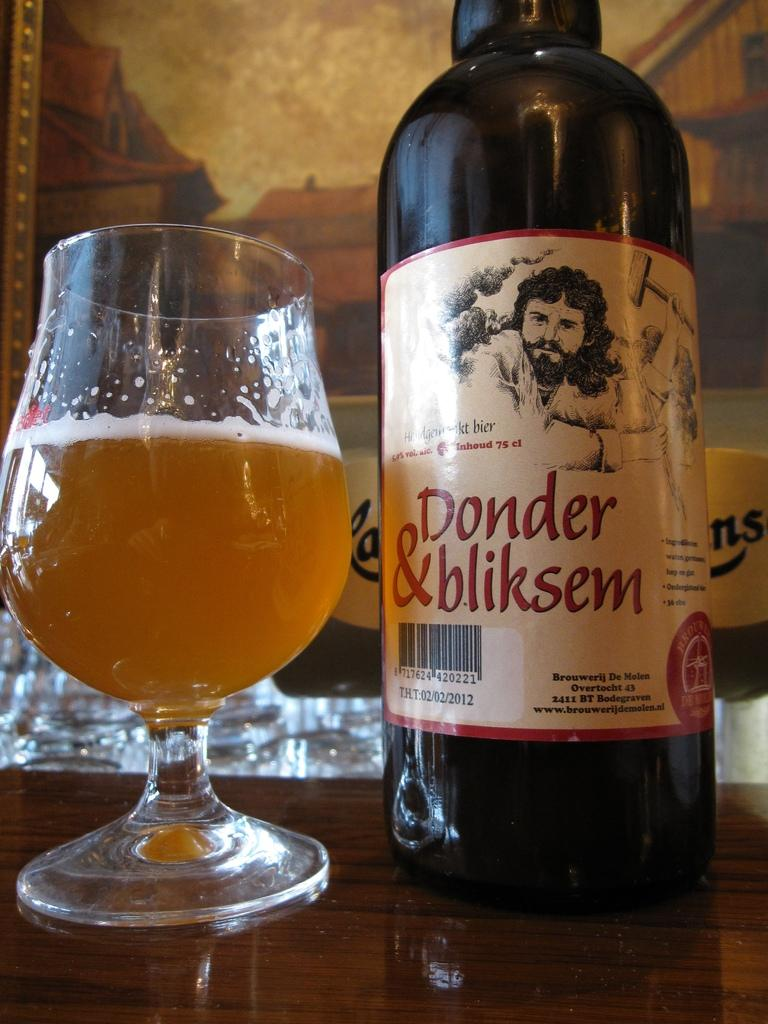Provide a one-sentence caption for the provided image. A bottle of Donder and bliskem beer sits on a table next to a glass of beer. 